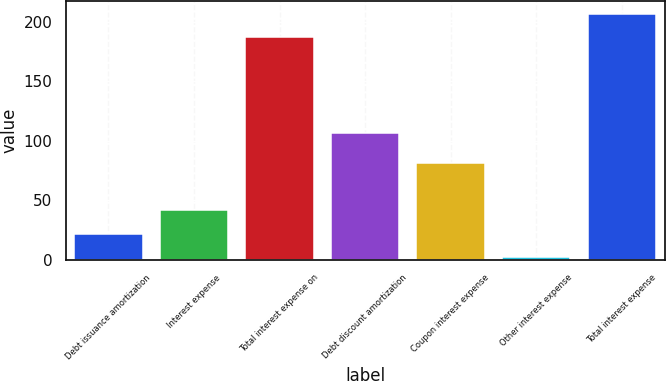<chart> <loc_0><loc_0><loc_500><loc_500><bar_chart><fcel>Debt issuance amortization<fcel>Interest expense<fcel>Total interest expense on<fcel>Debt discount amortization<fcel>Coupon interest expense<fcel>Other interest expense<fcel>Total interest expense<nl><fcel>22.06<fcel>41.72<fcel>186.9<fcel>106.1<fcel>81.04<fcel>2.4<fcel>206.56<nl></chart> 